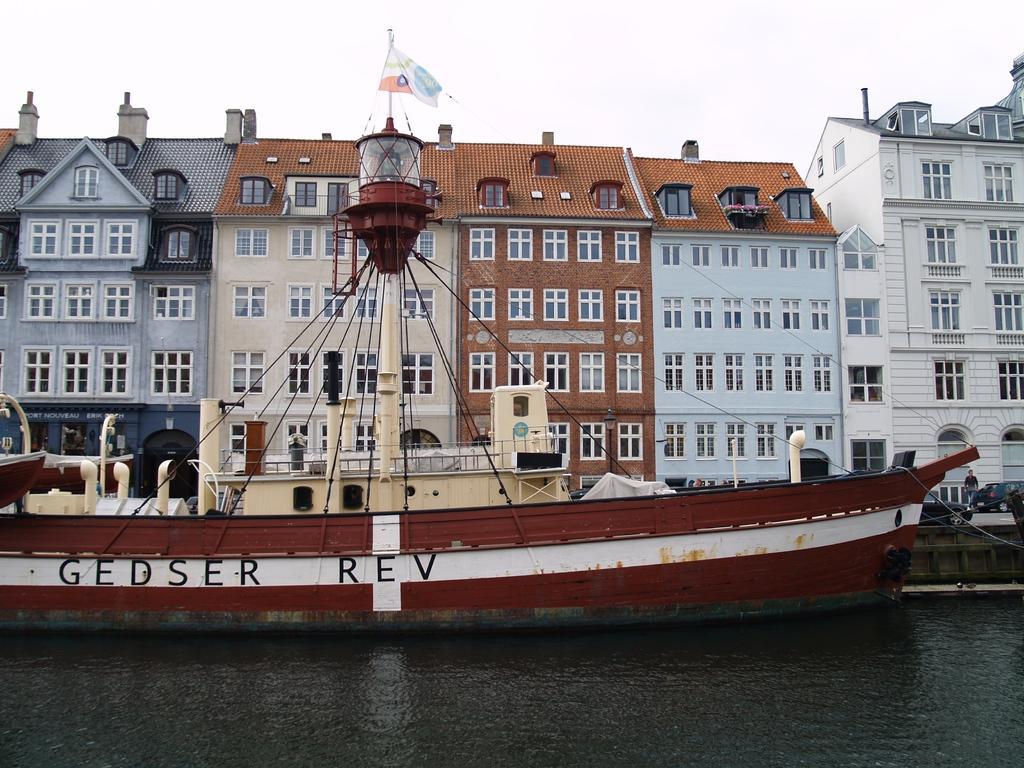Describe this image in one or two sentences. In this image we can see water, boat, flag, vehicles, buildings, and a person. In the background there is sky. 